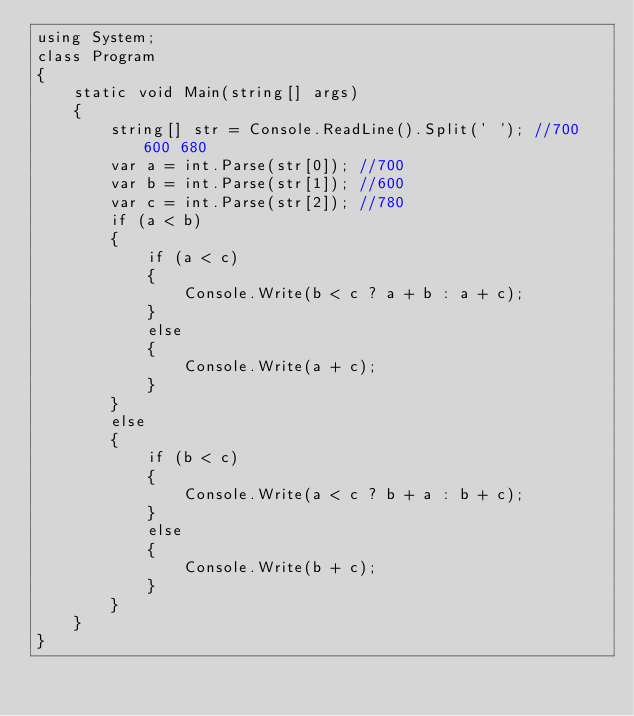<code> <loc_0><loc_0><loc_500><loc_500><_C#_>using System;
class Program
{
    static void Main(string[] args)
    {
        string[] str = Console.ReadLine().Split(' '); //700 600 680
        var a = int.Parse(str[0]); //700
        var b = int.Parse(str[1]); //600
        var c = int.Parse(str[2]); //780
        if (a < b)
        {
            if (a < c)
            {
                Console.Write(b < c ? a + b : a + c);
            }
            else
            {
                Console.Write(a + c);
            }
        }
        else
        {
            if (b < c)
            {
                Console.Write(a < c ? b + a : b + c);
            }
            else
            {
                Console.Write(b + c);
            }
        }
    }
}</code> 